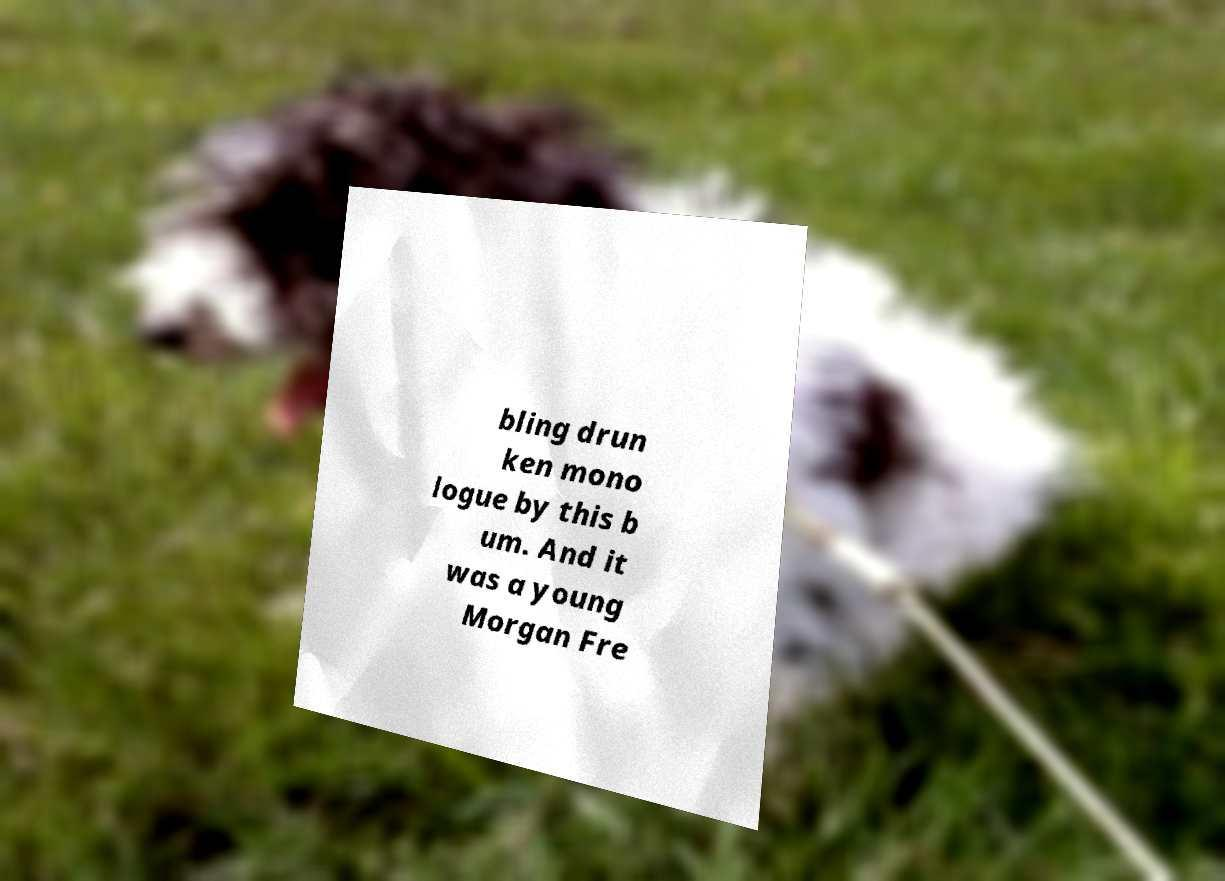There's text embedded in this image that I need extracted. Can you transcribe it verbatim? bling drun ken mono logue by this b um. And it was a young Morgan Fre 